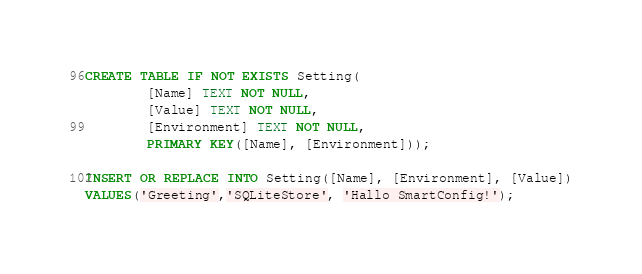Convert code to text. <code><loc_0><loc_0><loc_500><loc_500><_SQL_>CREATE TABLE IF NOT EXISTS Setting( 
        [Name] TEXT NOT NULL,
        [Value] TEXT NOT NULL, 
        [Environment] TEXT NOT NULL, 
        PRIMARY KEY([Name], [Environment]));

INSERT OR REPLACE INTO Setting([Name], [Environment], [Value])
VALUES('Greeting','SQLiteStore', 'Hallo SmartConfig!');

</code> 